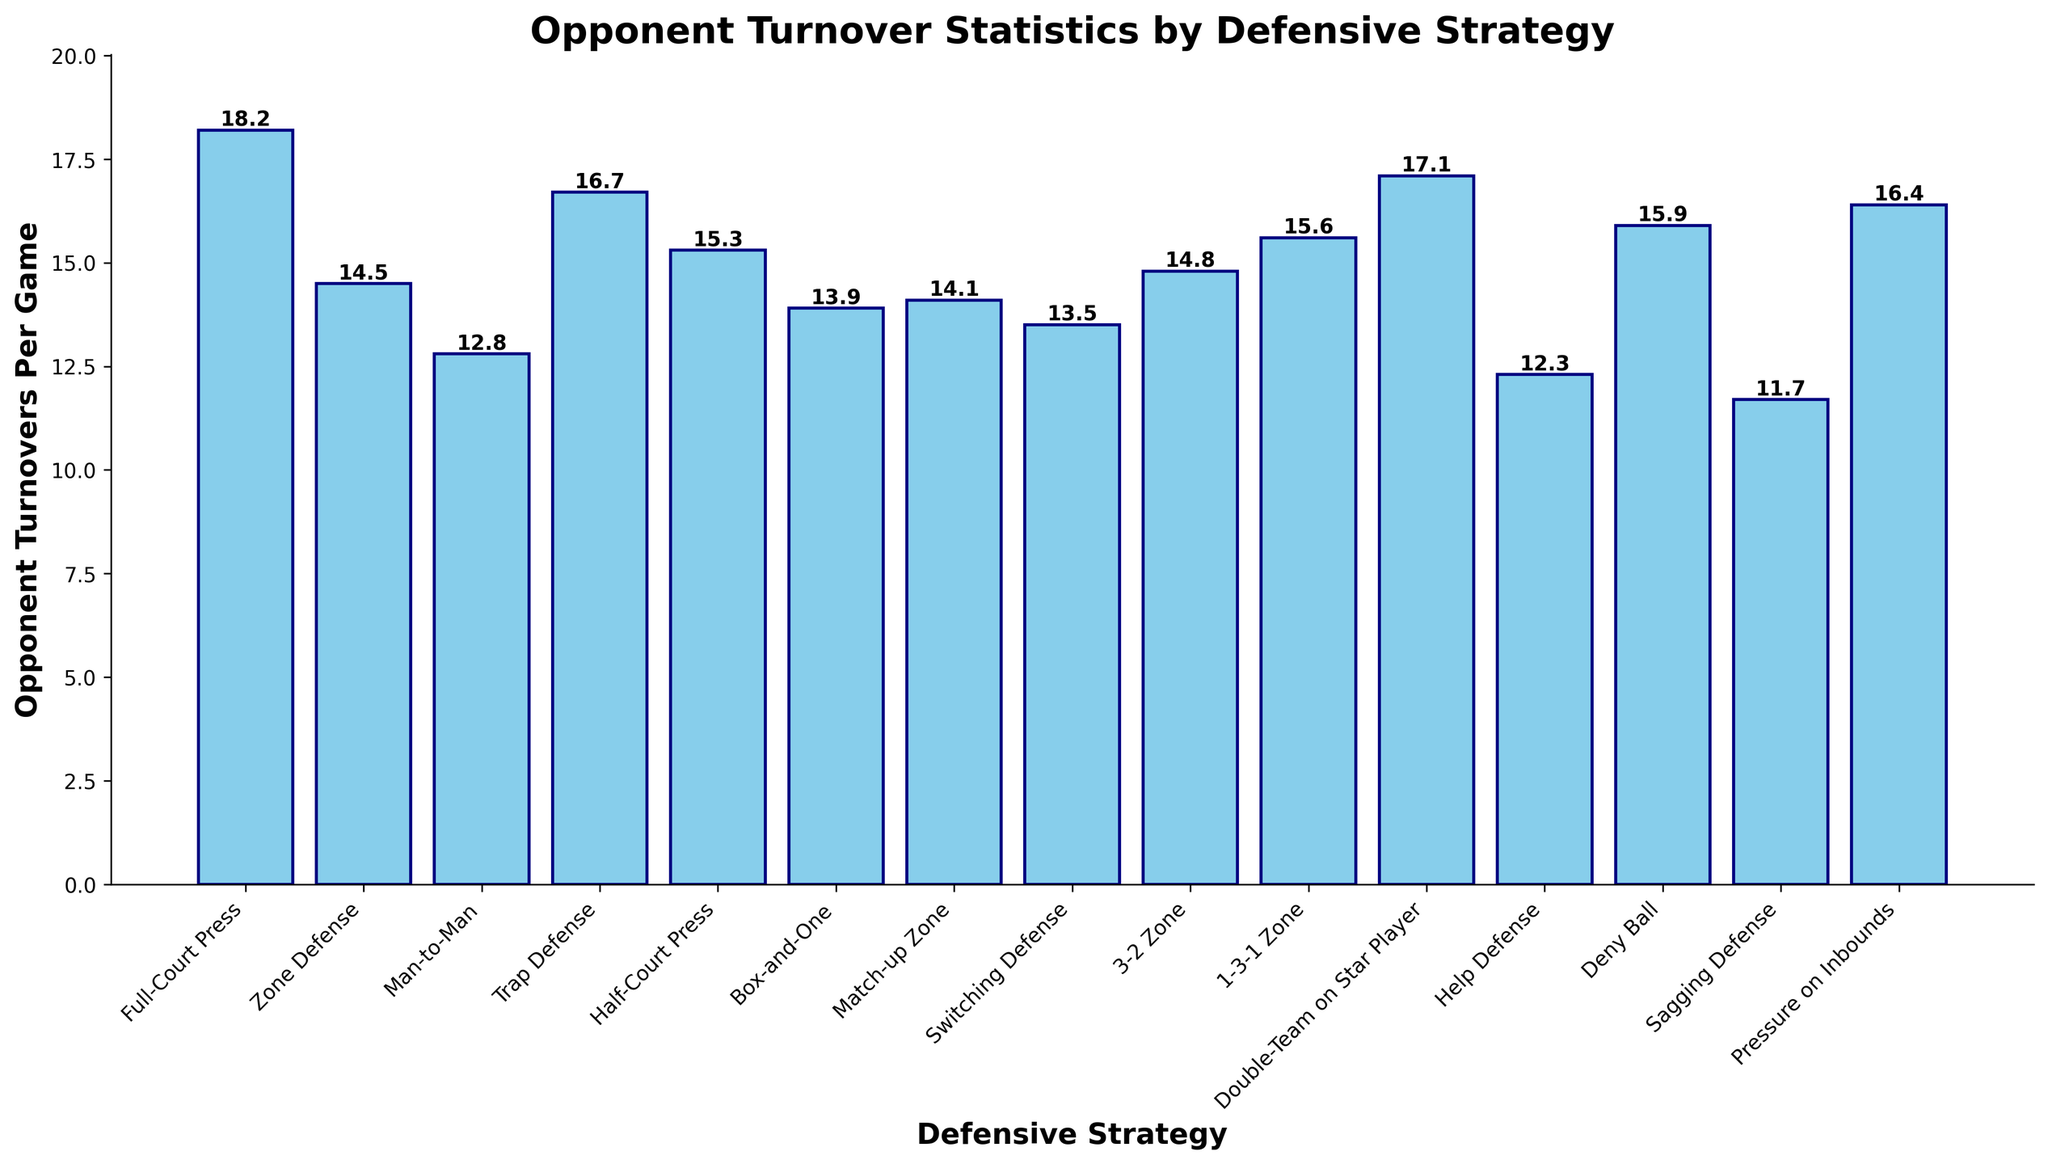Which defensive strategy results in the highest opponent turnovers per game? The highest bar corresponds to the 'Full-Court Press' defensive strategy, which results in an opponent turnover of 18.2 per game.
Answer: Full-Court Press Which defensive strategy results in the lowest opponent turnovers per game? The lowest bar corresponds to the 'Sagging Defense' strategy with an opponent turnover of 11.7 per game.
Answer: Sagging Defense Which defensive strategies cause opponent turnovers greater than 16 per game? Observing the bars that exceed the 16 mark on the y-axis, the 'Full-Court Press', 'Trap Defense', 'Double-Team on Star Player', and 'Pressure on Inbounds' defensive strategies cause turnovers greater than 16 per game.
Answer: Full-Court Press, Trap Defense, Double-Team on Star Player, Pressure on Inbounds What is the difference in opponent turnovers per game between the 'Full-Court Press' and 'Sagging Defense' strategies? The 'Full-Court Press' results in 18.2 turnovers per game and the 'Sagging Defense' results in 11.7 turnovers per game. The difference is 18.2 - 11.7.
Answer: 6.5 How many defensive strategies result in opponent turnovers of more than 15 per game? Counting the bars that have heights more than 15 on the y-axis: Full-Court Press, Trap Defense, 1-3-1 Zone, Double-Team on Star Player, Deny Ball, and Pressure on Inbounds. This gives us 6 strategies.
Answer: 6 Which strategy results in the closest to the median value of opponent turnovers per game? Listing the turnovers values: 11.7, 12.3, 12.8, 13.5, 13.9, 14.1, 14.5, 14.8, 15.3, 15.6, 15.9, 16.4, 16.7, 17.1, 18.2. The median is the middle value: 14.5. The 'Zone Defense' strategy has an opponent turnover of 14.5, which is the median.
Answer: Zone Defense Compare the opponent turnovers per game between 'Man-to-Man' and 'Help Defense'. Which is higher? The bar for 'Man-to-Man' is at 12.8 while the bar for 'Help Defense' is at 12.3. 'Man-to-Man' has higher opponent turnovers per game.
Answer: Man-to-Man What is the average opponent turnover rate for defensive strategies that have turnovers less than 14 per game? Strategies with turnovers less than 14: Sagging Defense (11.7), Help Defense (12.3), Man-to-Man (12.8), Switching Defense (13.5), Box-and-One (13.9). Average = (11.7 + 12.3 + 12.8 + 13.5 + 13.9) / 5.
Answer: 12.84 